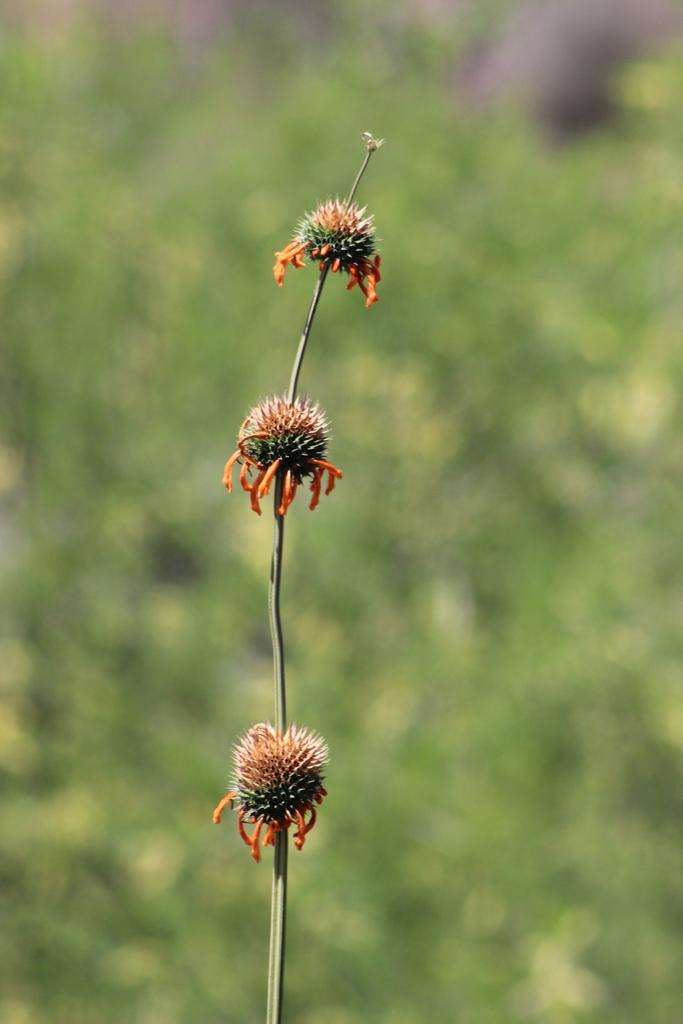What is the main subject of the picture? The main subject of the picture is dandelion flowers. Can you describe the background of the image? The background is green in color and blurred. What type of fruit can be seen hanging from the dandelion flowers in the image? There is no fruit hanging from the dandelion flowers in the image. Is there a carriage visible in the background of the image? There is no carriage present in the image. 